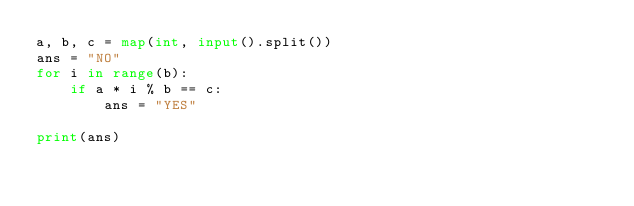Convert code to text. <code><loc_0><loc_0><loc_500><loc_500><_Python_>a, b, c = map(int, input().split())
ans = "NO"
for i in range(b):
    if a * i % b == c:
        ans = "YES"

print(ans)</code> 